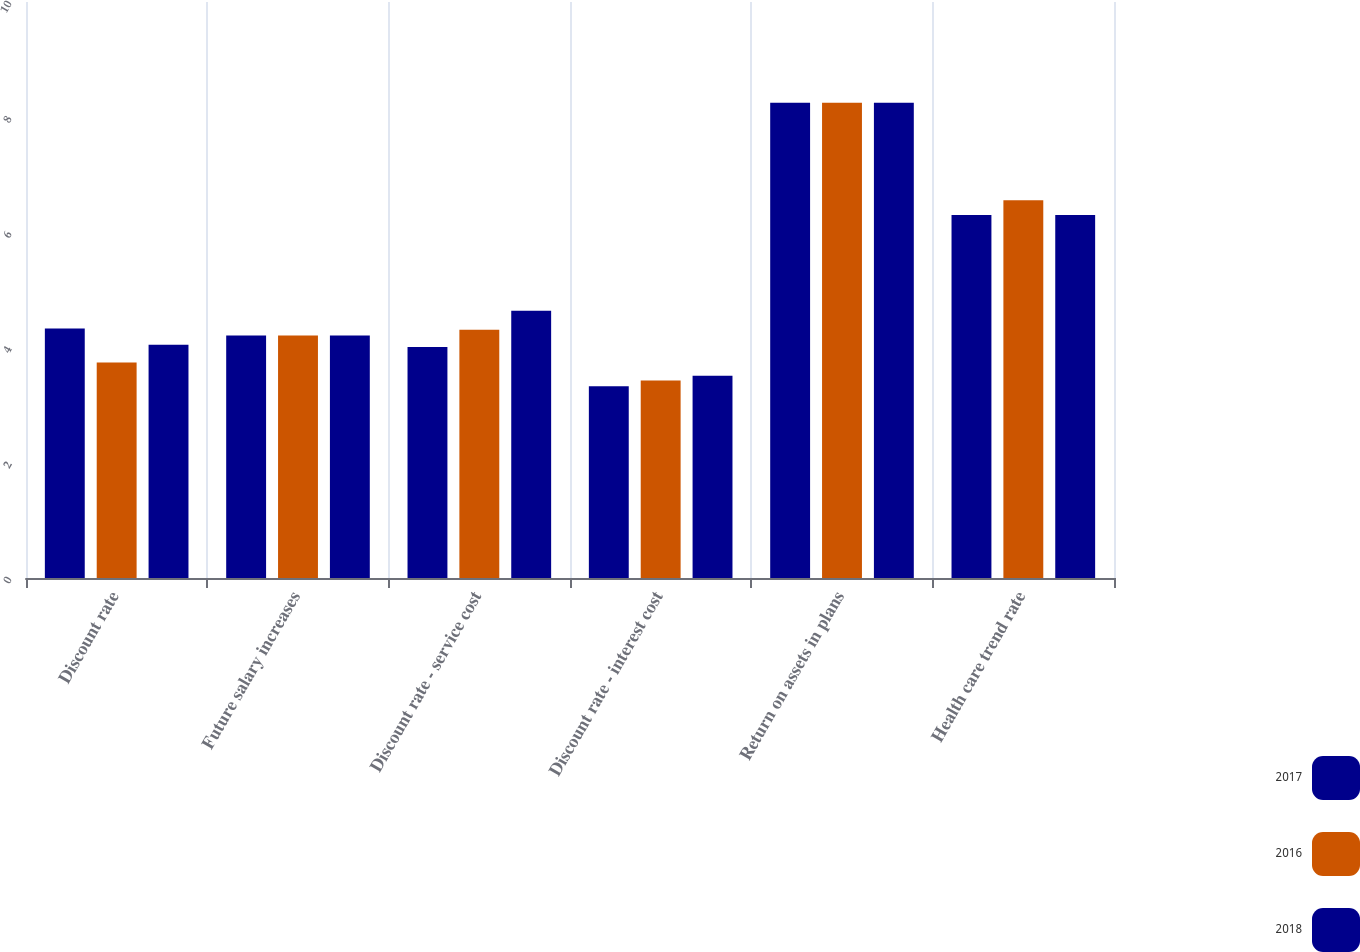Convert chart to OTSL. <chart><loc_0><loc_0><loc_500><loc_500><stacked_bar_chart><ecel><fcel>Discount rate<fcel>Future salary increases<fcel>Discount rate - service cost<fcel>Discount rate - interest cost<fcel>Return on assets in plans<fcel>Health care trend rate<nl><fcel>2017<fcel>4.33<fcel>4.21<fcel>4.01<fcel>3.33<fcel>8.25<fcel>6.3<nl><fcel>2016<fcel>3.74<fcel>4.21<fcel>4.31<fcel>3.43<fcel>8.25<fcel>6.56<nl><fcel>2018<fcel>4.05<fcel>4.21<fcel>4.64<fcel>3.51<fcel>8.25<fcel>6.3<nl></chart> 